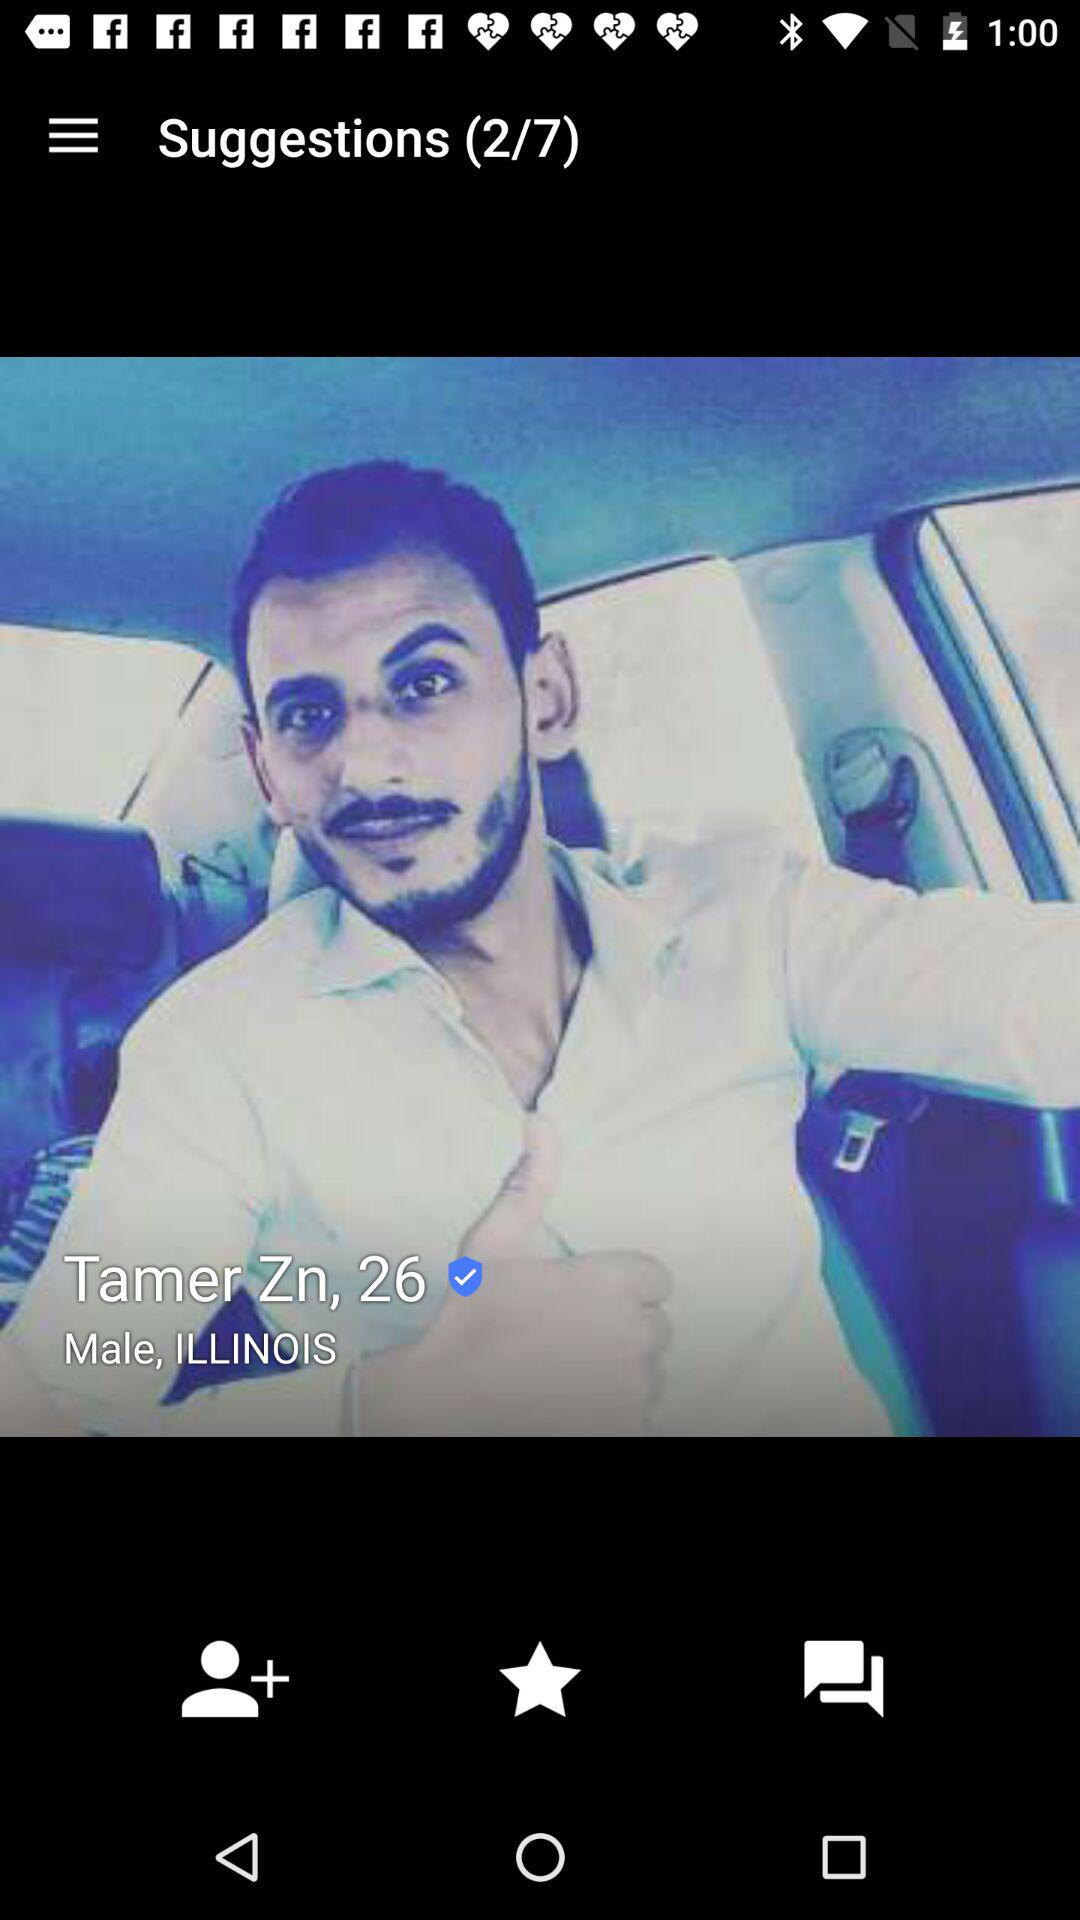What is the given name? The given name is "Tamer Zn". 